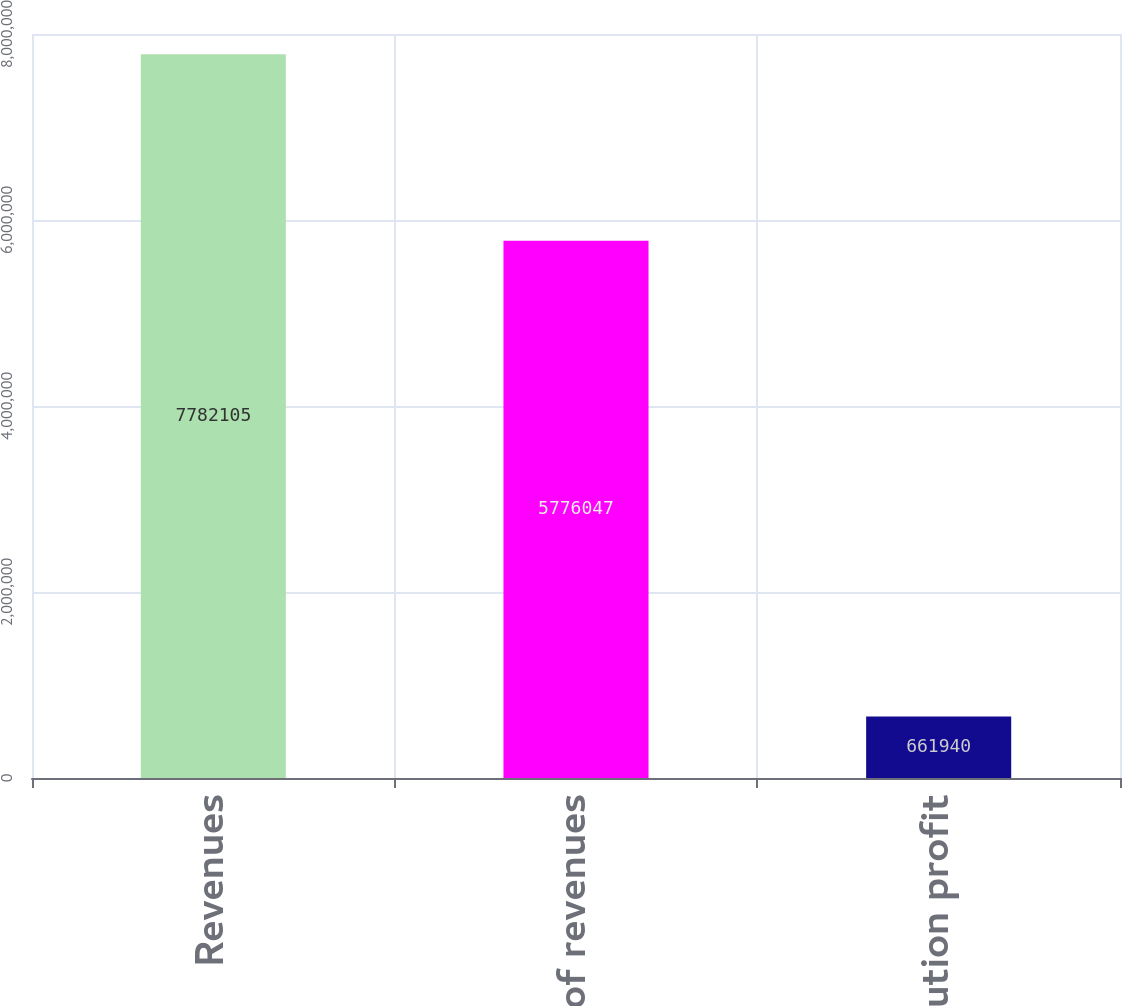<chart> <loc_0><loc_0><loc_500><loc_500><bar_chart><fcel>Revenues<fcel>Cost of revenues<fcel>Contribution profit<nl><fcel>7.7821e+06<fcel>5.77605e+06<fcel>661940<nl></chart> 